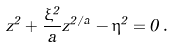<formula> <loc_0><loc_0><loc_500><loc_500>z ^ { 2 } + \frac { \xi ^ { 2 } } { a } z ^ { 2 / a } - \eta ^ { 2 } = 0 \, .</formula> 